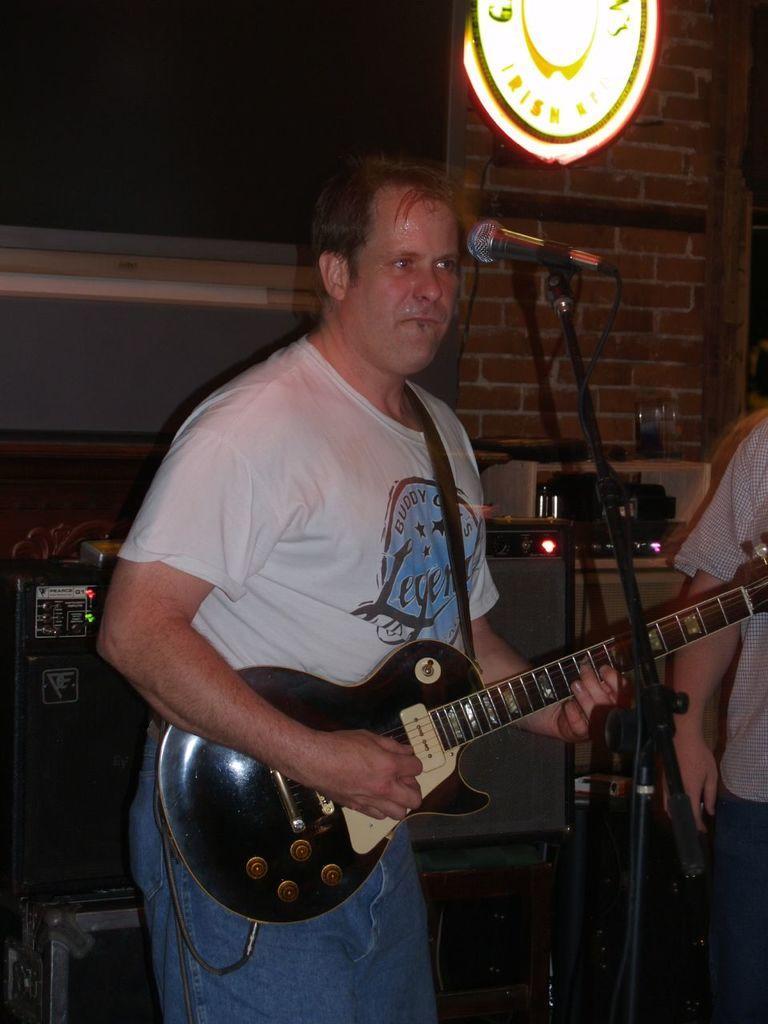How would you summarize this image in a sentence or two? A man who wore a white color tee shirt and blue jeans is holding the guitar and has a mike in front of him and some instruments in front of him. 